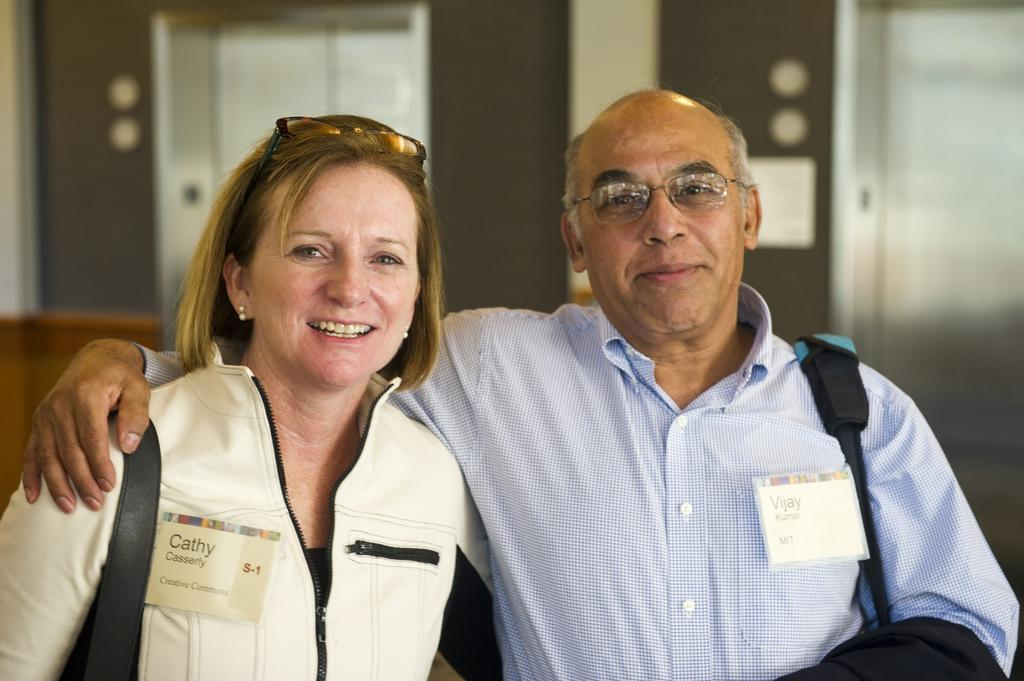How many people are in the image? There are two persons in the image. What can be seen on the persons in the image? The persons have tags. What architectural feature is visible in the background of the image? There are elevators visible in the background. What else can be seen in the background of the image? There is a wall in the background. What type of cup is being used to catch the jelly that is falling in the image? There is no cup or jelly present in the image. How does the jelly fall in the image? There is no jelly present in the image, so it cannot be falling. 